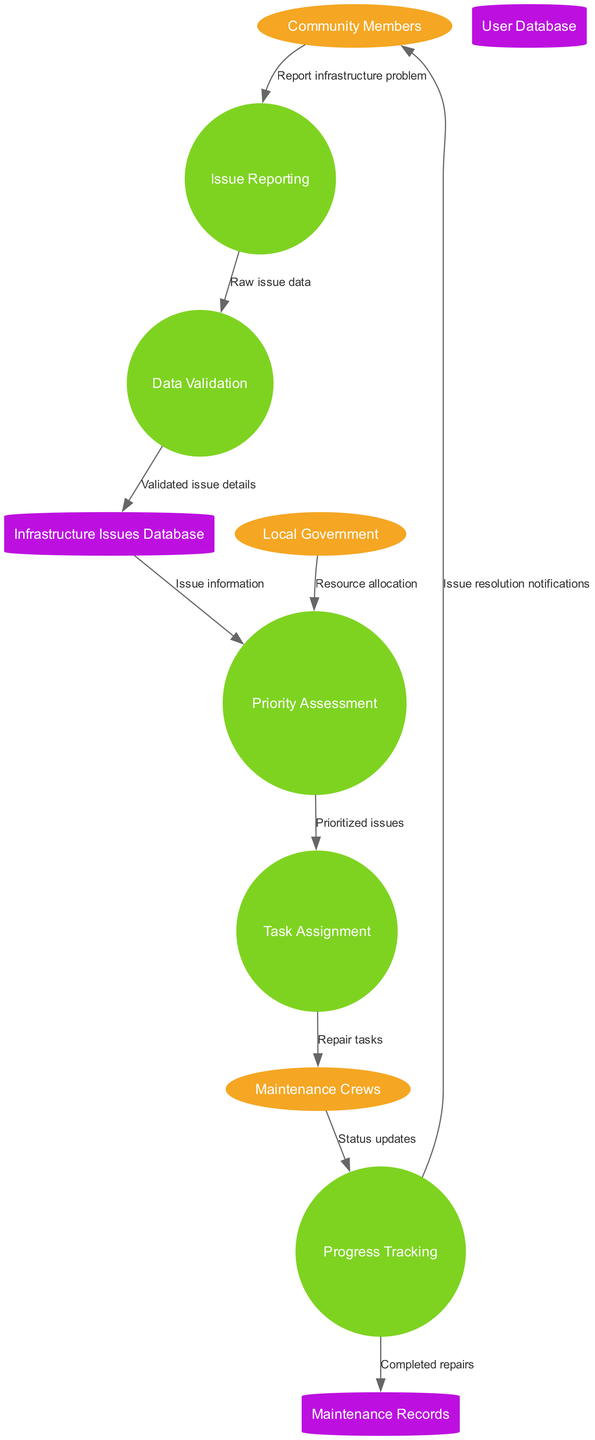What are the external entities in the diagram? The external entities listed in the diagram are Community Members, Local Government, and Maintenance Crews, which are shown as ellipses.
Answer: Community Members, Local Government, Maintenance Crews How many processes are defined in the diagram? By counting the circles representing the processes in the diagram, there are five distinct processes defined: Issue Reporting, Data Validation, Priority Assessment, Task Assignment, and Progress Tracking.
Answer: 5 What data flows from the Maintenance Crews to the Progress Tracking process? The data flow from Maintenance Crews to Progress Tracking is labeled as "Status updates."
Answer: Status updates Which entity sends resource allocation to the Priority Assessment process? The Local Government is the entity that sends resource allocation to the Priority Assessment process, as indicated by the directed flow in the diagram.
Answer: Local Government What is the final data flow before notifying Community Members about issue resolution? The last data flow before notifying Community Members is from Progress Tracking to Maintenance Records, labeled "Completed repairs."
Answer: Completed repairs Which process receives validated issue details? The process that receives validated issue details is Data Validation, as it follows the Issue Reporting process in the flow.
Answer: Data Validation After which process does the task assignment occur? The task assignment occurs after the Priority Assessment process, as indicated by the directed flow from Priority Assessment to Task Assignment.
Answer: Priority Assessment What is the purpose of the Infrastructure Issues Database? The purpose of the Infrastructure Issues Database is to store validated issue details received from the Data Validation process.
Answer: Store validated issue details How many data stores are represented in the diagram? The diagram contains three data stores: User Database, Infrastructure Issues Database, and Maintenance Records, which are shown as cylinders.
Answer: 3 